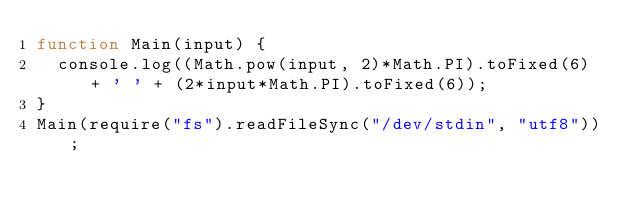<code> <loc_0><loc_0><loc_500><loc_500><_JavaScript_>function Main(input) {
  console.log((Math.pow(input, 2)*Math.PI).toFixed(6) + ' ' + (2*input*Math.PI).toFixed(6));
}
Main(require("fs").readFileSync("/dev/stdin", "utf8"));

</code> 